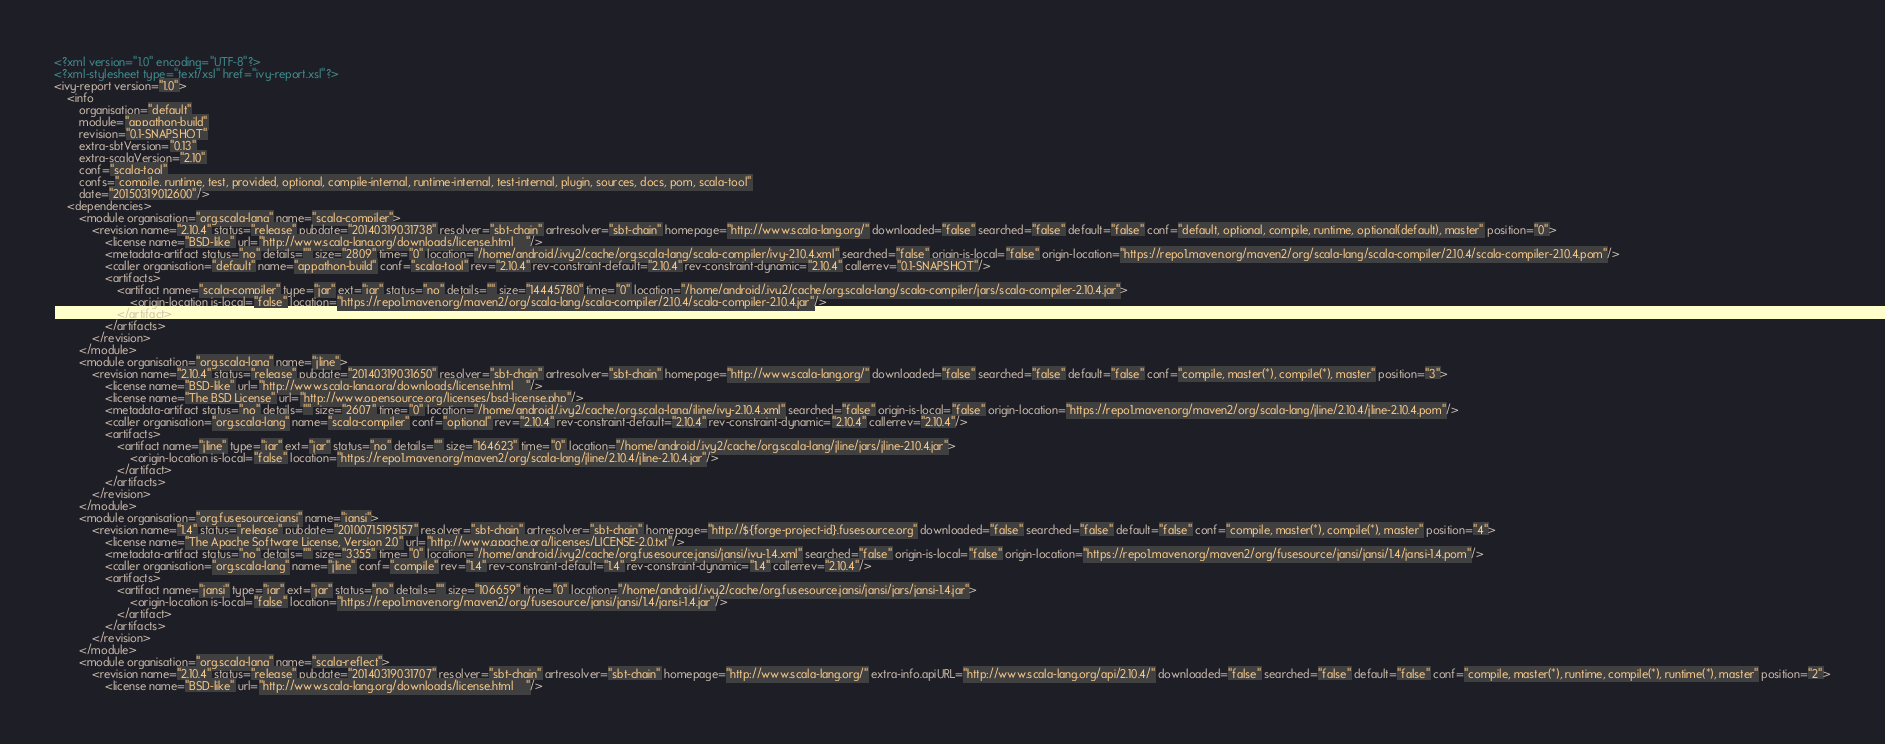Convert code to text. <code><loc_0><loc_0><loc_500><loc_500><_XML_><?xml version="1.0" encoding="UTF-8"?>
<?xml-stylesheet type="text/xsl" href="ivy-report.xsl"?>
<ivy-report version="1.0">
	<info
		organisation="default"
		module="appathon-build"
		revision="0.1-SNAPSHOT"
		extra-sbtVersion="0.13"
		extra-scalaVersion="2.10"
		conf="scala-tool"
		confs="compile, runtime, test, provided, optional, compile-internal, runtime-internal, test-internal, plugin, sources, docs, pom, scala-tool"
		date="20150319012600"/>
	<dependencies>
		<module organisation="org.scala-lang" name="scala-compiler">
			<revision name="2.10.4" status="release" pubdate="20140319031738" resolver="sbt-chain" artresolver="sbt-chain" homepage="http://www.scala-lang.org/" downloaded="false" searched="false" default="false" conf="default, optional, compile, runtime, optional(default), master" position="0">
				<license name="BSD-like" url="http://www.scala-lang.org/downloads/license.html    "/>
				<metadata-artifact status="no" details="" size="2809" time="0" location="/home/android/.ivy2/cache/org.scala-lang/scala-compiler/ivy-2.10.4.xml" searched="false" origin-is-local="false" origin-location="https://repo1.maven.org/maven2/org/scala-lang/scala-compiler/2.10.4/scala-compiler-2.10.4.pom"/>
				<caller organisation="default" name="appathon-build" conf="scala-tool" rev="2.10.4" rev-constraint-default="2.10.4" rev-constraint-dynamic="2.10.4" callerrev="0.1-SNAPSHOT"/>
				<artifacts>
					<artifact name="scala-compiler" type="jar" ext="jar" status="no" details="" size="14445780" time="0" location="/home/android/.ivy2/cache/org.scala-lang/scala-compiler/jars/scala-compiler-2.10.4.jar">
						<origin-location is-local="false" location="https://repo1.maven.org/maven2/org/scala-lang/scala-compiler/2.10.4/scala-compiler-2.10.4.jar"/>
					</artifact>
				</artifacts>
			</revision>
		</module>
		<module organisation="org.scala-lang" name="jline">
			<revision name="2.10.4" status="release" pubdate="20140319031650" resolver="sbt-chain" artresolver="sbt-chain" homepage="http://www.scala-lang.org/" downloaded="false" searched="false" default="false" conf="compile, master(*), compile(*), master" position="3">
				<license name="BSD-like" url="http://www.scala-lang.org/downloads/license.html    "/>
				<license name="The BSD License" url="http://www.opensource.org/licenses/bsd-license.php"/>
				<metadata-artifact status="no" details="" size="2607" time="0" location="/home/android/.ivy2/cache/org.scala-lang/jline/ivy-2.10.4.xml" searched="false" origin-is-local="false" origin-location="https://repo1.maven.org/maven2/org/scala-lang/jline/2.10.4/jline-2.10.4.pom"/>
				<caller organisation="org.scala-lang" name="scala-compiler" conf="optional" rev="2.10.4" rev-constraint-default="2.10.4" rev-constraint-dynamic="2.10.4" callerrev="2.10.4"/>
				<artifacts>
					<artifact name="jline" type="jar" ext="jar" status="no" details="" size="164623" time="0" location="/home/android/.ivy2/cache/org.scala-lang/jline/jars/jline-2.10.4.jar">
						<origin-location is-local="false" location="https://repo1.maven.org/maven2/org/scala-lang/jline/2.10.4/jline-2.10.4.jar"/>
					</artifact>
				</artifacts>
			</revision>
		</module>
		<module organisation="org.fusesource.jansi" name="jansi">
			<revision name="1.4" status="release" pubdate="20100715195157" resolver="sbt-chain" artresolver="sbt-chain" homepage="http://${forge-project-id}.fusesource.org" downloaded="false" searched="false" default="false" conf="compile, master(*), compile(*), master" position="4">
				<license name="The Apache Software License, Version 2.0" url="http://www.apache.org/licenses/LICENSE-2.0.txt"/>
				<metadata-artifact status="no" details="" size="3355" time="0" location="/home/android/.ivy2/cache/org.fusesource.jansi/jansi/ivy-1.4.xml" searched="false" origin-is-local="false" origin-location="https://repo1.maven.org/maven2/org/fusesource/jansi/jansi/1.4/jansi-1.4.pom"/>
				<caller organisation="org.scala-lang" name="jline" conf="compile" rev="1.4" rev-constraint-default="1.4" rev-constraint-dynamic="1.4" callerrev="2.10.4"/>
				<artifacts>
					<artifact name="jansi" type="jar" ext="jar" status="no" details="" size="106659" time="0" location="/home/android/.ivy2/cache/org.fusesource.jansi/jansi/jars/jansi-1.4.jar">
						<origin-location is-local="false" location="https://repo1.maven.org/maven2/org/fusesource/jansi/jansi/1.4/jansi-1.4.jar"/>
					</artifact>
				</artifacts>
			</revision>
		</module>
		<module organisation="org.scala-lang" name="scala-reflect">
			<revision name="2.10.4" status="release" pubdate="20140319031707" resolver="sbt-chain" artresolver="sbt-chain" homepage="http://www.scala-lang.org/" extra-info.apiURL="http://www.scala-lang.org/api/2.10.4/" downloaded="false" searched="false" default="false" conf="compile, master(*), runtime, compile(*), runtime(*), master" position="2">
				<license name="BSD-like" url="http://www.scala-lang.org/downloads/license.html    "/></code> 